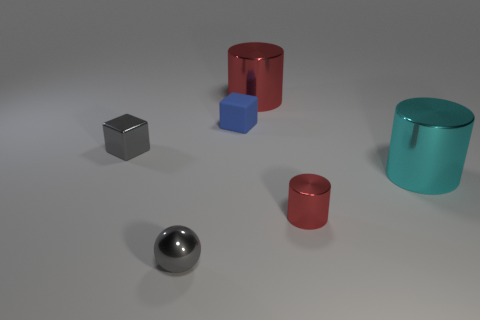What is the texture of the objects? The objects in the image all possess a smooth and highly reflective surface, suggesting they are likely made from materials such as metal or polished plastic. 